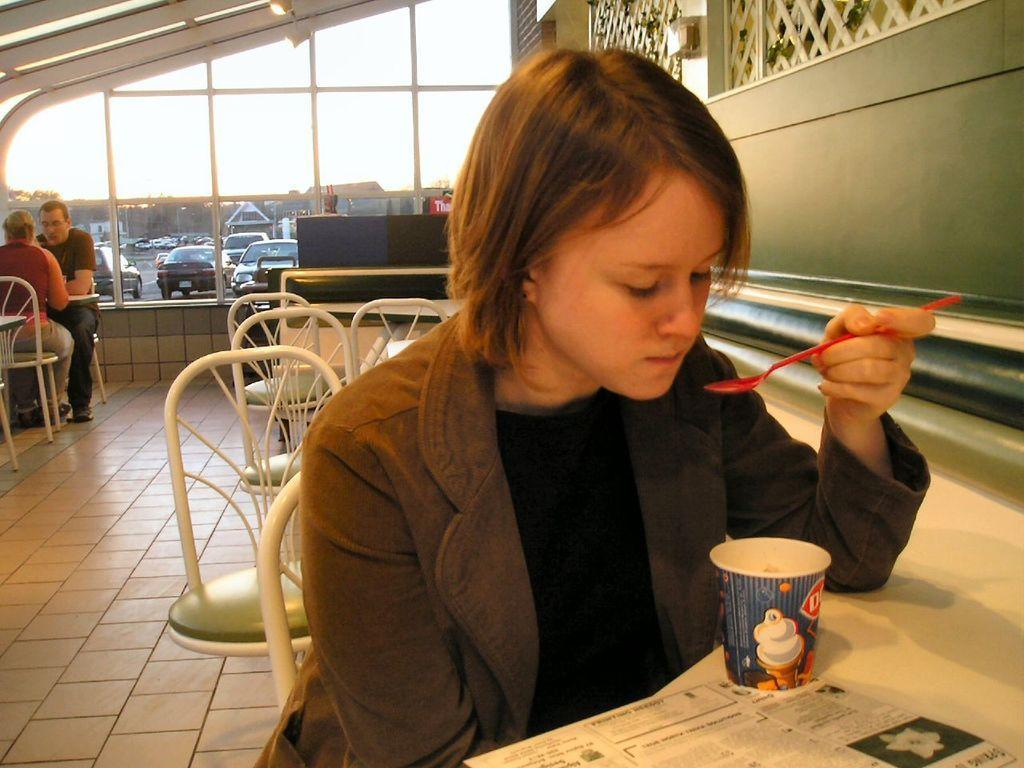Can you describe this image briefly? Here in the front we can see a lady sitting on a chair with ice cream in front of her she is eating the ice cream and behind her on the left side we can see a couple of people sitting on chairs and behind them there are number of cars present 